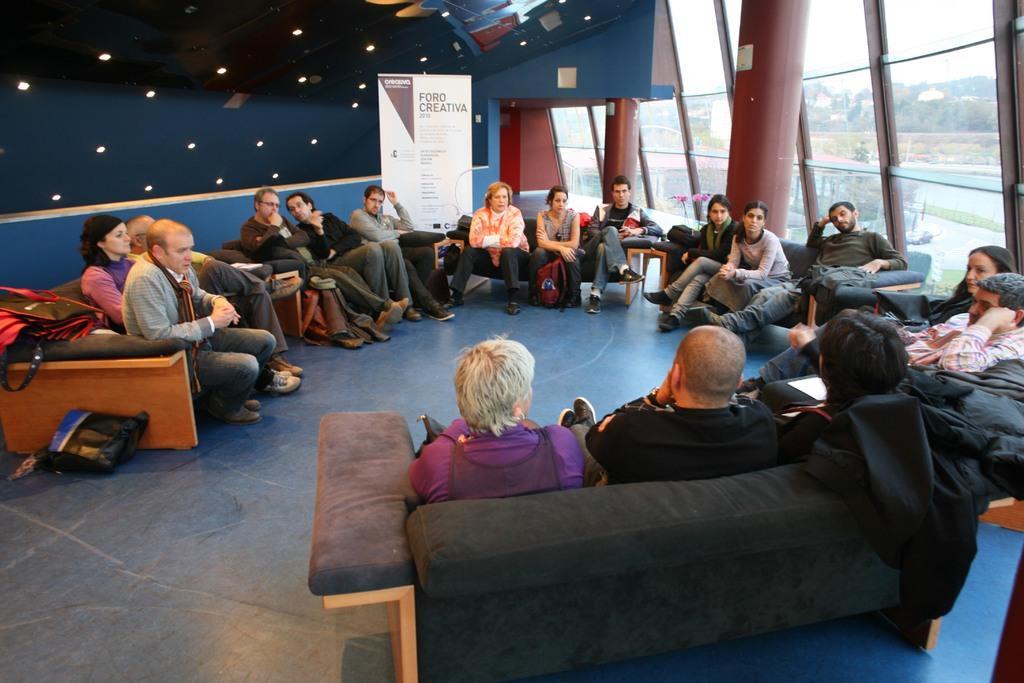Please provide a concise description of this image. This is an inside view. Here I can see many people are sitting on the couches and there are few bags. At the back of these people there is a board on which I can see some text. In the background there are many lights. On the right side there are two pillars and a glass through which we can see the outside view. In the outside there are many trees and also I can see the sky. 